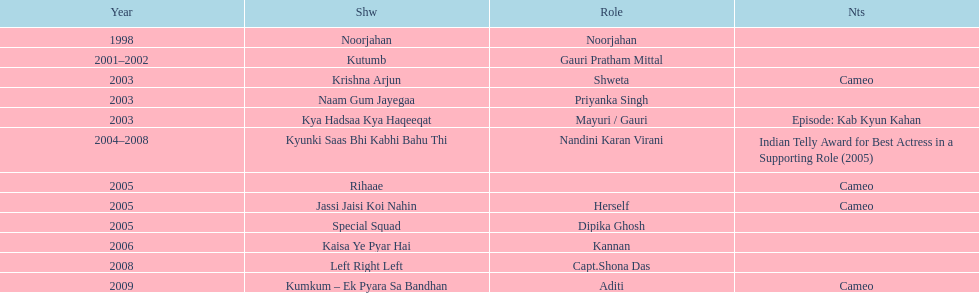Other than rihaae, in what alternate show did gauri tejwani have a guest appearance in 2005? Jassi Jaisi Koi Nahin. 